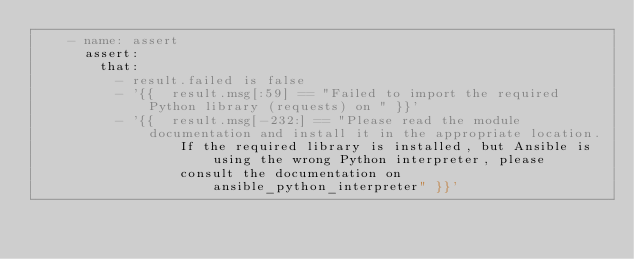<code> <loc_0><loc_0><loc_500><loc_500><_YAML_>    - name: assert
      assert:
        that:
          - result.failed is false
          - '{{  result.msg[:59] == "Failed to import the required Python library (requests) on " }}'
          - '{{  result.msg[-232:] == "Please read the module documentation and install it in the appropriate location.
                  If the required library is installed, but Ansible is using the wrong Python interpreter, please
                  consult the documentation on ansible_python_interpreter" }}'</code> 